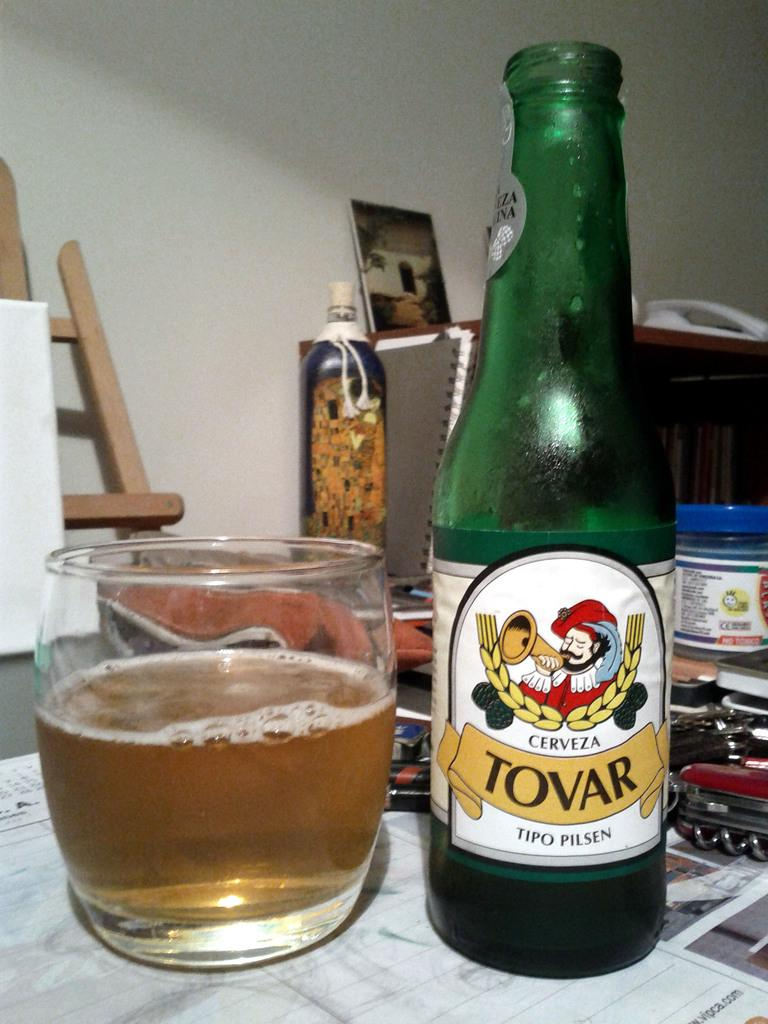Provide a one-sentence caption for the provided image. Tovar beer bottle next to a small cup of beer. 